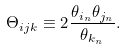Convert formula to latex. <formula><loc_0><loc_0><loc_500><loc_500>\Theta _ { i j k } \equiv 2 \frac { \theta _ { i _ { n } } \theta _ { j _ { n } } } { \theta _ { k _ { n } } } .</formula> 